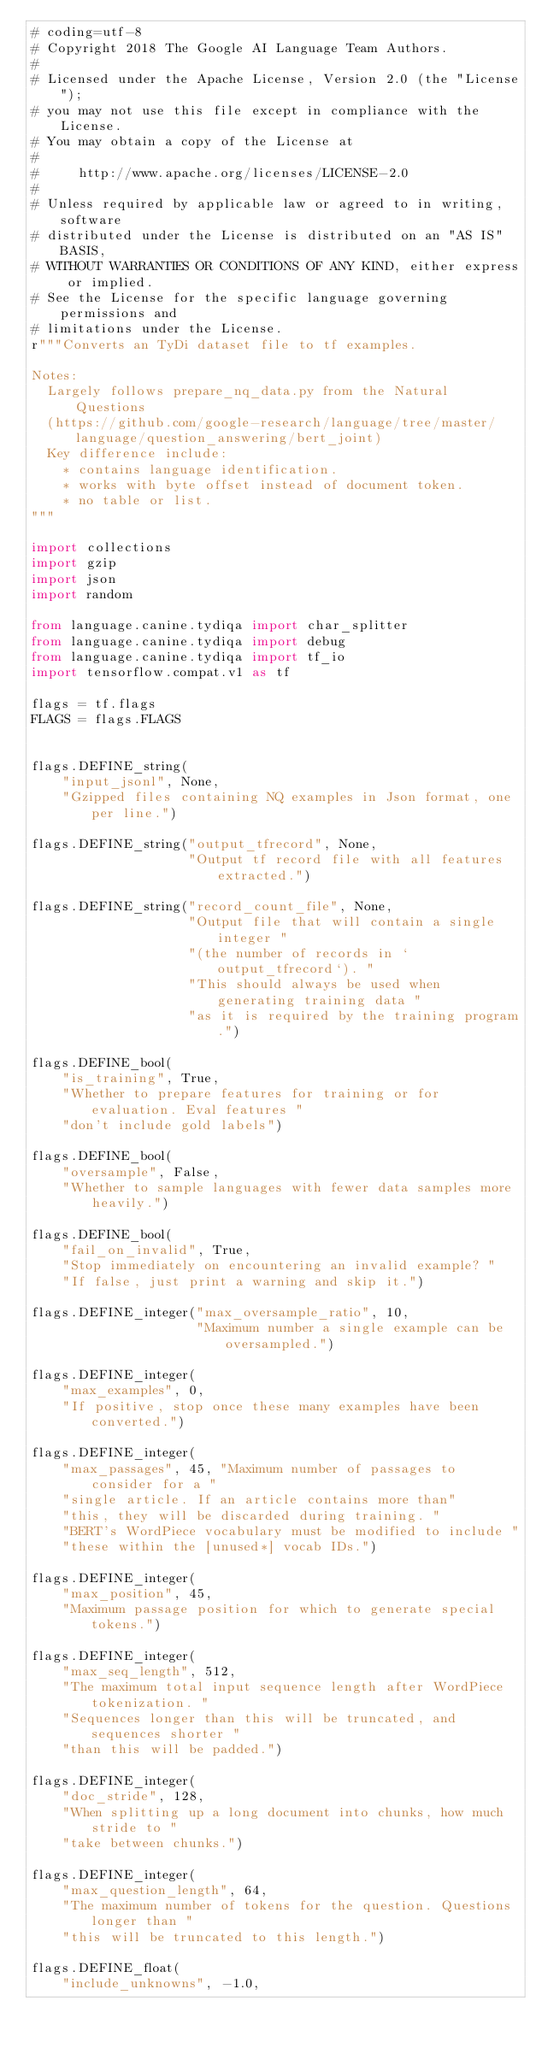Convert code to text. <code><loc_0><loc_0><loc_500><loc_500><_Python_># coding=utf-8
# Copyright 2018 The Google AI Language Team Authors.
#
# Licensed under the Apache License, Version 2.0 (the "License");
# you may not use this file except in compliance with the License.
# You may obtain a copy of the License at
#
#     http://www.apache.org/licenses/LICENSE-2.0
#
# Unless required by applicable law or agreed to in writing, software
# distributed under the License is distributed on an "AS IS" BASIS,
# WITHOUT WARRANTIES OR CONDITIONS OF ANY KIND, either express or implied.
# See the License for the specific language governing permissions and
# limitations under the License.
r"""Converts an TyDi dataset file to tf examples.

Notes:
  Largely follows prepare_nq_data.py from the Natural Questions
  (https://github.com/google-research/language/tree/master/language/question_answering/bert_joint)
  Key difference include:
    * contains language identification.
    * works with byte offset instead of document token.
    * no table or list.
"""

import collections
import gzip
import json
import random

from language.canine.tydiqa import char_splitter
from language.canine.tydiqa import debug
from language.canine.tydiqa import tf_io
import tensorflow.compat.v1 as tf

flags = tf.flags
FLAGS = flags.FLAGS


flags.DEFINE_string(
    "input_jsonl", None,
    "Gzipped files containing NQ examples in Json format, one per line.")

flags.DEFINE_string("output_tfrecord", None,
                    "Output tf record file with all features extracted.")

flags.DEFINE_string("record_count_file", None,
                    "Output file that will contain a single integer "
                    "(the number of records in `output_tfrecord`). "
                    "This should always be used when generating training data "
                    "as it is required by the training program.")

flags.DEFINE_bool(
    "is_training", True,
    "Whether to prepare features for training or for evaluation. Eval features "
    "don't include gold labels")

flags.DEFINE_bool(
    "oversample", False,
    "Whether to sample languages with fewer data samples more heavily.")

flags.DEFINE_bool(
    "fail_on_invalid", True,
    "Stop immediately on encountering an invalid example? "
    "If false, just print a warning and skip it.")

flags.DEFINE_integer("max_oversample_ratio", 10,
                     "Maximum number a single example can be oversampled.")

flags.DEFINE_integer(
    "max_examples", 0,
    "If positive, stop once these many examples have been converted.")

flags.DEFINE_integer(
    "max_passages", 45, "Maximum number of passages to consider for a "
    "single article. If an article contains more than"
    "this, they will be discarded during training. "
    "BERT's WordPiece vocabulary must be modified to include "
    "these within the [unused*] vocab IDs.")

flags.DEFINE_integer(
    "max_position", 45,
    "Maximum passage position for which to generate special tokens.")

flags.DEFINE_integer(
    "max_seq_length", 512,
    "The maximum total input sequence length after WordPiece tokenization. "
    "Sequences longer than this will be truncated, and sequences shorter "
    "than this will be padded.")

flags.DEFINE_integer(
    "doc_stride", 128,
    "When splitting up a long document into chunks, how much stride to "
    "take between chunks.")

flags.DEFINE_integer(
    "max_question_length", 64,
    "The maximum number of tokens for the question. Questions longer than "
    "this will be truncated to this length.")

flags.DEFINE_float(
    "include_unknowns", -1.0,</code> 